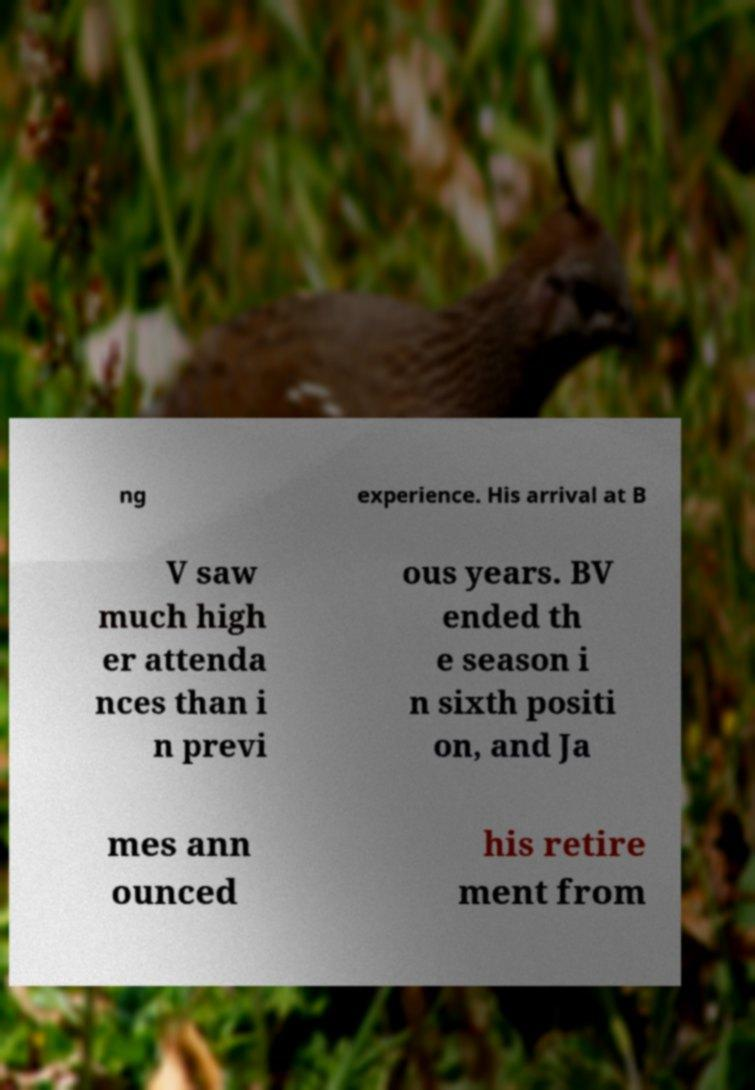Please read and relay the text visible in this image. What does it say? ng experience. His arrival at B V saw much high er attenda nces than i n previ ous years. BV ended th e season i n sixth positi on, and Ja mes ann ounced his retire ment from 